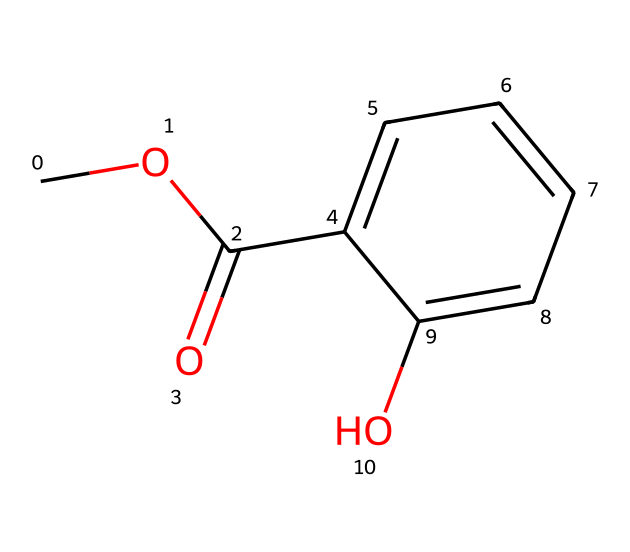What is the name of the ester represented by the SMILES? The SMILES indicates a compound with a methoxy group (OCH3) and a salicylic acid moiety (C1=CC=CC=C1O), which collectively is named methyl salicylate.
Answer: methyl salicylate How many carbon atoms are present in this compound? Analyzing the structure shows 9 carbon atoms in total: 7 from the aromatic ring and 2 from the ester functional group (O-CH3 and C(=O)).
Answer: 9 What functional groups are present in methyl salicylate? The visible features include an ester group (indicated by C(=O)O) and a hydroxyl group (OH) on the aromatic ring, making both functional groups present in the structure.
Answer: ester and hydroxyl Is methyl salicylate a liquid or solid at room temperature? Given that methyl salicylate has low melting and boiling points, it is typically in a liquid state at room temperature.
Answer: liquid What type of reaction forms esters like methyl salicylate? The structure of methyl salicylate suggests it is formed through a condensation reaction between an alcohol (methanol) and a carboxylic acid (salicylic acid).
Answer: condensation What is the role of the methoxy group in methyl salicylate? The methoxy group helps in increasing the solubility of the ester and plays a role in the scent and flavor properties typically associated with esters.
Answer: increases solubility How many double bonds does methyl salicylate contain? The analysis of the structure reveals that there is one double bond in the carbonyl group (C=O) of the ester and another in the aromatic ring, yielding a total of two double bonds.
Answer: 2 